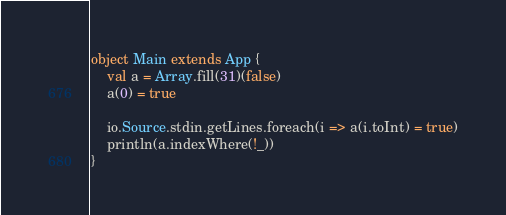Convert code to text. <code><loc_0><loc_0><loc_500><loc_500><_Scala_>object Main extends App {
    val a = Array.fill(31)(false)
    a(0) = true

    io.Source.stdin.getLines.foreach(i => a(i.toInt) = true)
    println(a.indexWhere(!_))
}</code> 